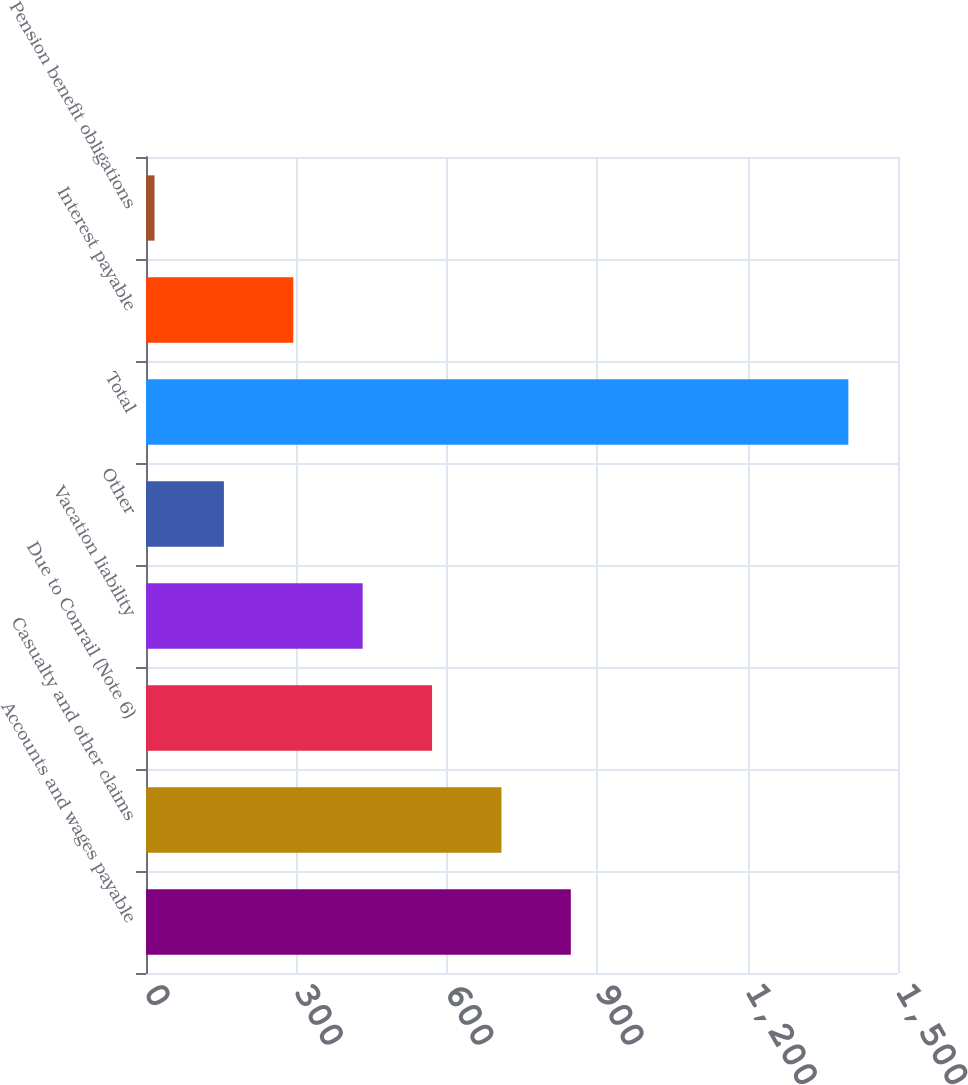Convert chart. <chart><loc_0><loc_0><loc_500><loc_500><bar_chart><fcel>Accounts and wages payable<fcel>Casualty and other claims<fcel>Due to Conrail (Note 6)<fcel>Vacation liability<fcel>Other<fcel>Total<fcel>Interest payable<fcel>Pension benefit obligations<nl><fcel>847.4<fcel>709<fcel>570.6<fcel>432.2<fcel>155.4<fcel>1401<fcel>293.8<fcel>17<nl></chart> 